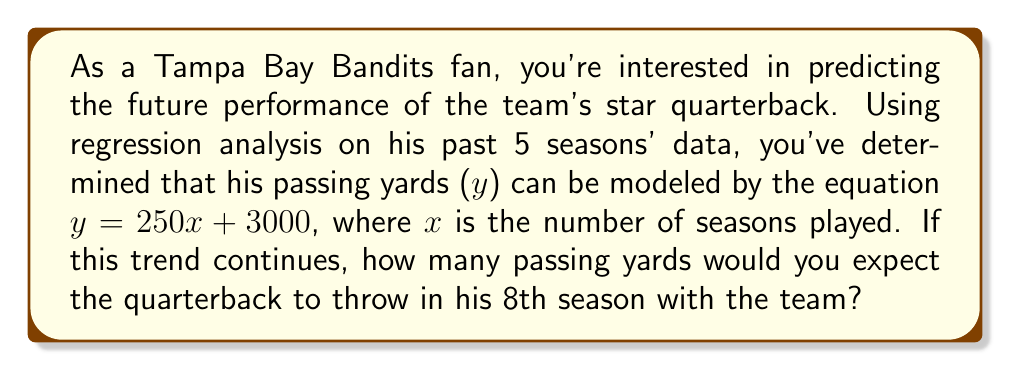Teach me how to tackle this problem. To solve this problem, we'll use the linear regression model provided:

$y = 250x + 3000$

Where:
$y$ = passing yards
$x$ = number of seasons played
$250$ = slope (increase in passing yards per season)
$3000$ = y-intercept (base passing yards)

We want to predict the passing yards for the 8th season, so we'll substitute $x = 8$ into the equation:

$y = 250(8) + 3000$

Now, let's solve step-by-step:

1) First, multiply 250 by 8:
   $y = 2000 + 3000$

2) Then, add 2000 and 3000:
   $y = 5000$

Therefore, based on this regression model, we would expect the quarterback to throw for 5000 yards in his 8th season with the Tampa Bay Bandits.
Answer: 5000 yards 